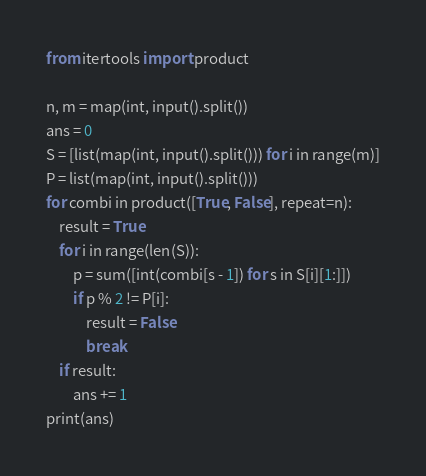<code> <loc_0><loc_0><loc_500><loc_500><_Python_>from itertools import product

n, m = map(int, input().split())
ans = 0
S = [list(map(int, input().split())) for i in range(m)]
P = list(map(int, input().split()))
for combi in product([True, False], repeat=n):
    result = True
    for i in range(len(S)):
        p = sum([int(combi[s - 1]) for s in S[i][1:]])
        if p % 2 != P[i]:
            result = False
            break
    if result:
        ans += 1
print(ans)
</code> 